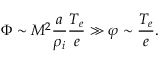<formula> <loc_0><loc_0><loc_500><loc_500>\Phi \sim M ^ { 2 } \frac { a } { \rho _ { i } } \frac { T _ { e } } { e } \gg \varphi \sim \frac { T _ { e } } { e } .</formula> 